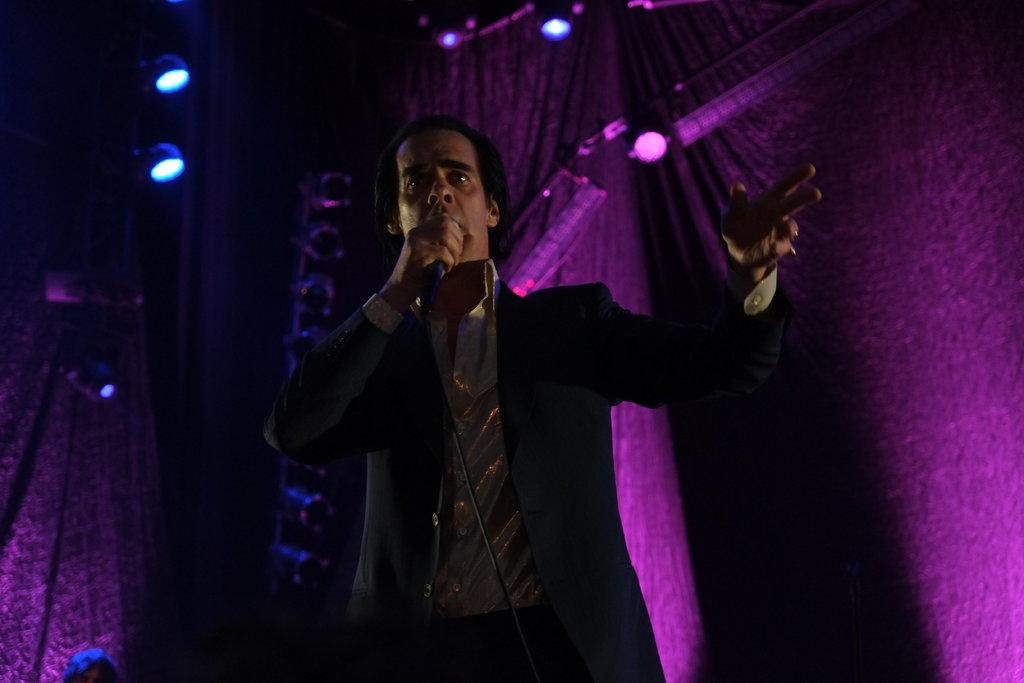Who is the main subject in the image? There is a man in the image. What is the man doing in the image? The man is speaking in the image. What tool is the man using to amplify his voice? The man is using a microphone in the image. What can be seen in the background of the image? There are lights and curtains in the background of the image. What type of development can be seen in the image? There is no development visible in the image; it features a man speaking with a microphone, and the background includes lights and curtains. How many birds are present in the image? There are no birds present in the image. 